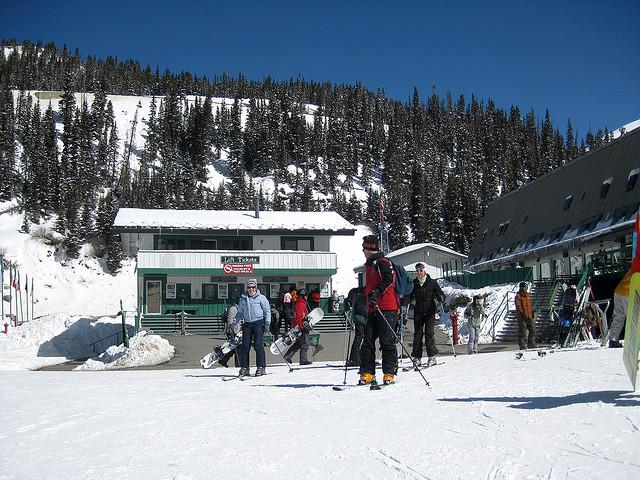Is that snow?
Concise answer only. Yes. What are these people preparing to do?
Write a very short answer. Ski. How many people are there?
Write a very short answer. 11. 